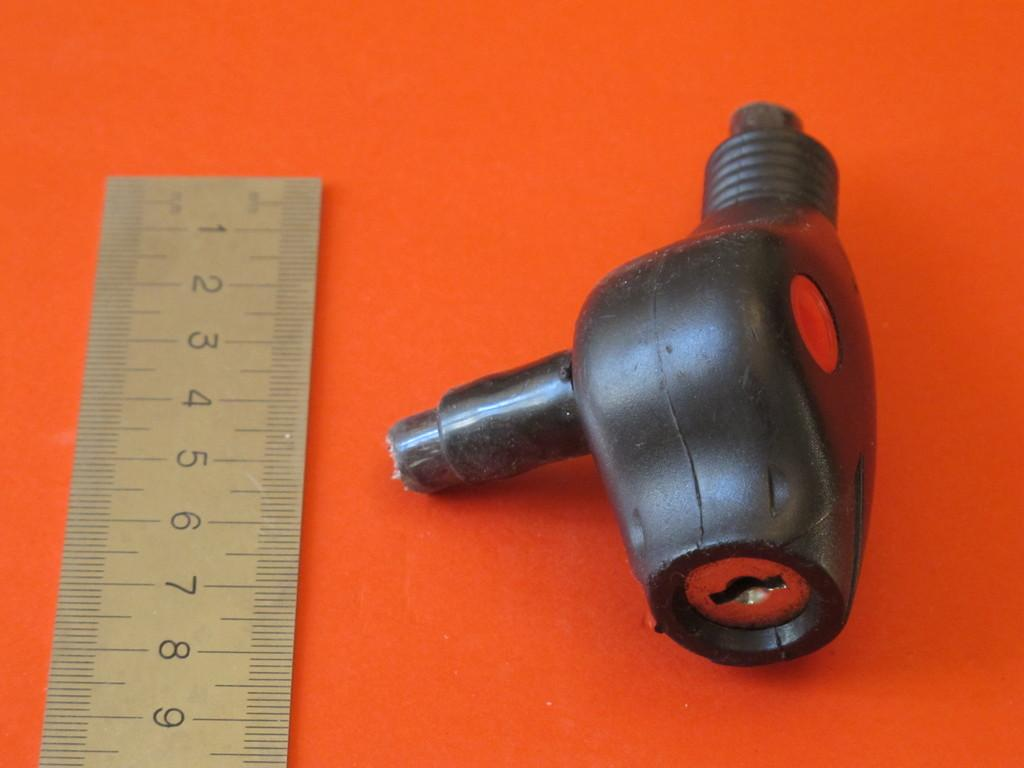<image>
Provide a brief description of the given image. The lock is approximately eight centimeters in length 